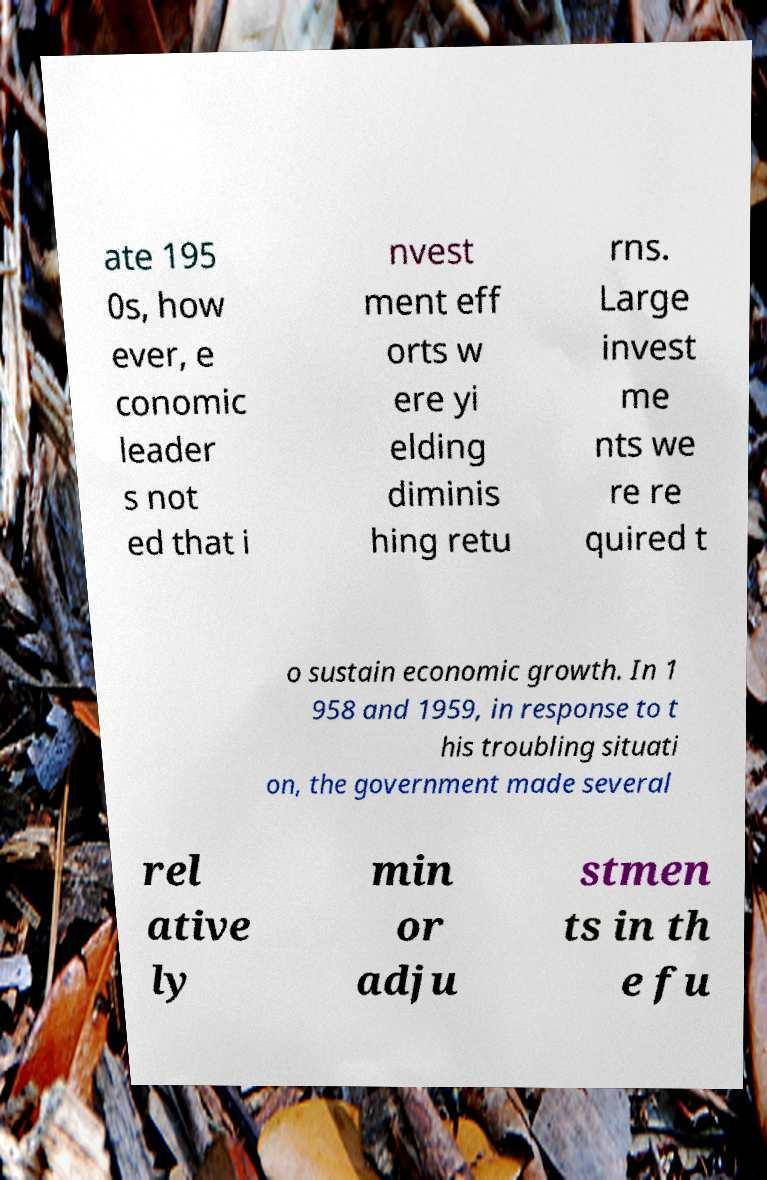Could you assist in decoding the text presented in this image and type it out clearly? ate 195 0s, how ever, e conomic leader s not ed that i nvest ment eff orts w ere yi elding diminis hing retu rns. Large invest me nts we re re quired t o sustain economic growth. In 1 958 and 1959, in response to t his troubling situati on, the government made several rel ative ly min or adju stmen ts in th e fu 